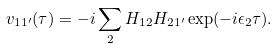<formula> <loc_0><loc_0><loc_500><loc_500>v _ { 1 1 ^ { \prime } } ( \tau ) = - i \sum _ { 2 } H _ { 1 2 } H _ { 2 1 ^ { \prime } } \exp ( - i \epsilon _ { 2 } \tau ) .</formula> 